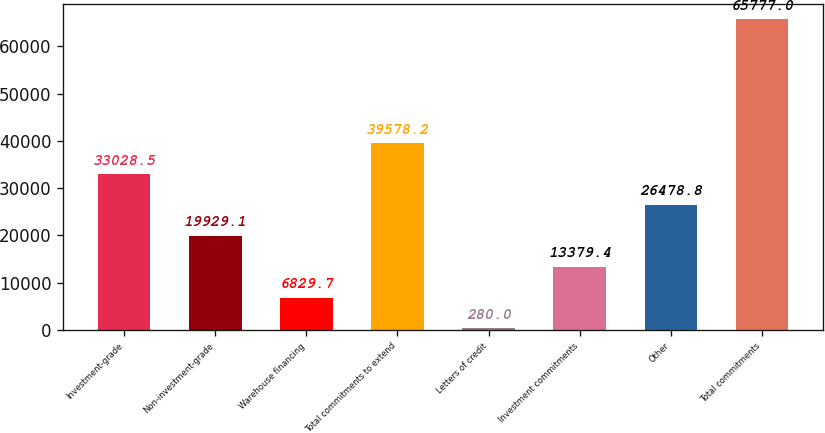Convert chart. <chart><loc_0><loc_0><loc_500><loc_500><bar_chart><fcel>Investment-grade<fcel>Non-investment-grade<fcel>Warehouse financing<fcel>Total commitments to extend<fcel>Letters of credit<fcel>Investment commitments<fcel>Other<fcel>Total commitments<nl><fcel>33028.5<fcel>19929.1<fcel>6829.7<fcel>39578.2<fcel>280<fcel>13379.4<fcel>26478.8<fcel>65777<nl></chart> 